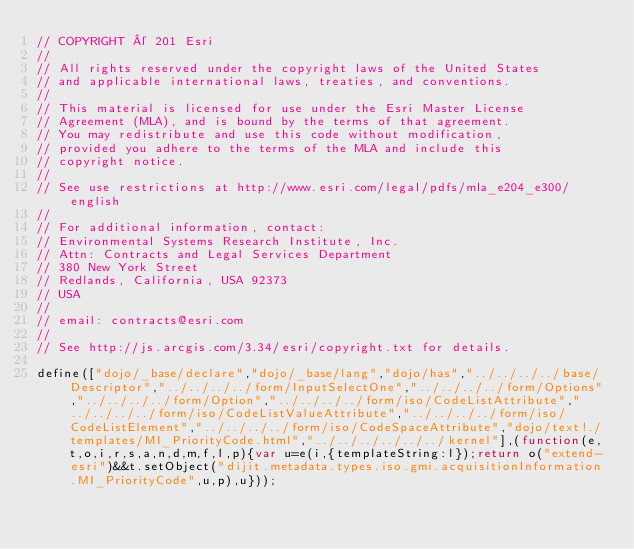Convert code to text. <code><loc_0><loc_0><loc_500><loc_500><_JavaScript_>// COPYRIGHT © 201 Esri
//
// All rights reserved under the copyright laws of the United States
// and applicable international laws, treaties, and conventions.
//
// This material is licensed for use under the Esri Master License
// Agreement (MLA), and is bound by the terms of that agreement.
// You may redistribute and use this code without modification,
// provided you adhere to the terms of the MLA and include this
// copyright notice.
//
// See use restrictions at http://www.esri.com/legal/pdfs/mla_e204_e300/english
//
// For additional information, contact:
// Environmental Systems Research Institute, Inc.
// Attn: Contracts and Legal Services Department
// 380 New York Street
// Redlands, California, USA 92373
// USA
//
// email: contracts@esri.com
//
// See http://js.arcgis.com/3.34/esri/copyright.txt for details.

define(["dojo/_base/declare","dojo/_base/lang","dojo/has","../../../../base/Descriptor","../../../../form/InputSelectOne","../../../../form/Options","../../../../form/Option","../../../../form/iso/CodeListAttribute","../../../../form/iso/CodeListValueAttribute","../../../../form/iso/CodeListElement","../../../../form/iso/CodeSpaceAttribute","dojo/text!./templates/MI_PriorityCode.html","../../../../../../kernel"],(function(e,t,o,i,r,s,a,n,d,m,f,l,p){var u=e(i,{templateString:l});return o("extend-esri")&&t.setObject("dijit.metadata.types.iso.gmi.acquisitionInformation.MI_PriorityCode",u,p),u}));</code> 